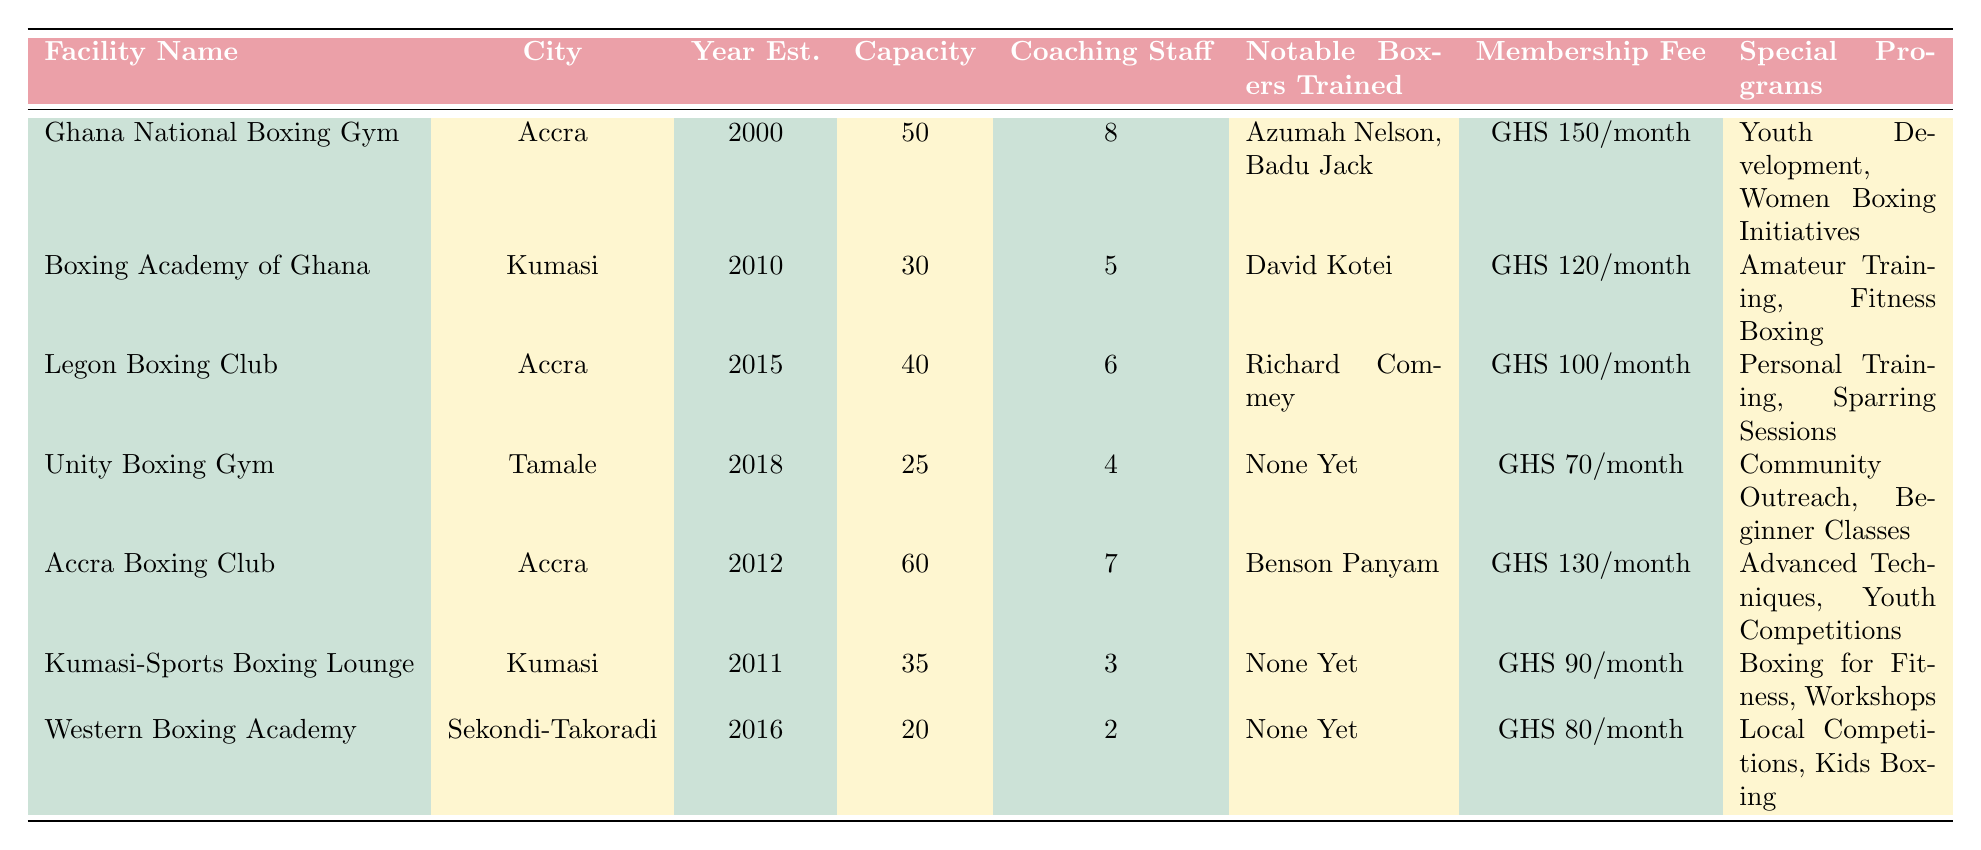What is the membership fee for the Ghana National Boxing Gym? The membership fee for the Ghana National Boxing Gym is listed directly in the table under the "Membership Fee" column. It states "GHS 150 per month".
Answer: GHS 150 per month Which boxing facility was established first? By comparing the "Year Est." column in the table, the Ghana National Boxing Gym, established in 2000, has the earliest year compared to the other facilities.
Answer: Ghana National Boxing Gym How many coaching staff members are at the Unity Boxing Gym? The Unity Boxing Gym has 4 coaching staff members according to the "Coaching Staff" column in the table.
Answer: 4 What is the capacity of the Accra Boxing Club? The "Capacity" column shows that the Accra Boxing Club has a capacity of 60 members, which is the highest among the listed facilities.
Answer: 60 Which city has more boxing facilities listed in the table? By counting the entries for each city in the "City" column, Accra has 3 facilities, Kumasi has 2, and the other cities (Tamale and Sekondi-Takoradi) each have 1. Thus, Accra has the most facilities.
Answer: Accra What is the average capacity of the boxing facilities listed in the table? To find the average, sum the capacities of all facilities: (50 + 30 + 40 + 25 + 60 + 35 + 20) = 260. There are 7 facilities, so the average capacity is 260/7 ≈ 37.14.
Answer: Approximately 37.14 Is there any facility that has a membership fee below GHS 80? Checking the "Membership Fee" column, the lowest fee listed is GHS 70 for the Unity Boxing Gym, which is below GHS 80.
Answer: Yes How many notable boxers have been trained at the Western Boxing Academy? The "Notable Boxers Trained" for the Western Boxing Academy indicates "None Yet", meaning no notable boxers have been trained there.
Answer: None What special programs are offered by the Boxing Academy of Ghana? The table lists "Amateur Training" and "Fitness Boxing" as the special programs for the Boxing Academy of Ghana under the "Special Programs" column.
Answer: Amateur Training, Fitness Boxing Which facility has the highest membership fee, and what is it? The highest membership fee listed is GHS 150 per month for the Ghana National Boxing Gym, as shown in the "Membership Fee" column.
Answer: Ghana National Boxing Gym; GHS 150 per month What is the total number of coaching staff at all boxing facilities combined? Adding the coaching staff counts together gives 8 (Ghana National Boxing Gym) + 5 (Boxing Academy of Ghana) + 6 (Legon Boxing Club) + 4 (Unity Boxing Gym) + 7 (Accra Boxing Club) + 3 (Kumasi-Sports Boxing Lounge) + 2 (Western Boxing Academy) = 35 coaching staff members in total.
Answer: 35 